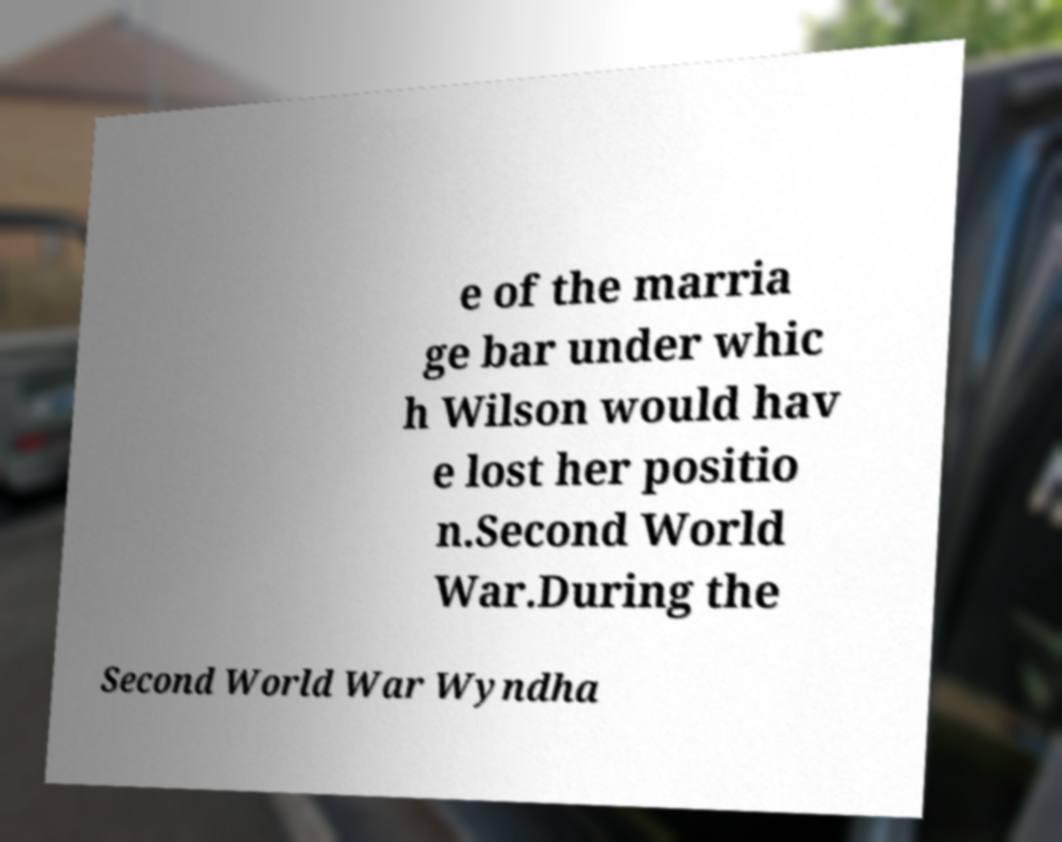Could you extract and type out the text from this image? e of the marria ge bar under whic h Wilson would hav e lost her positio n.Second World War.During the Second World War Wyndha 